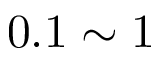<formula> <loc_0><loc_0><loc_500><loc_500>0 . 1 \sim 1</formula> 